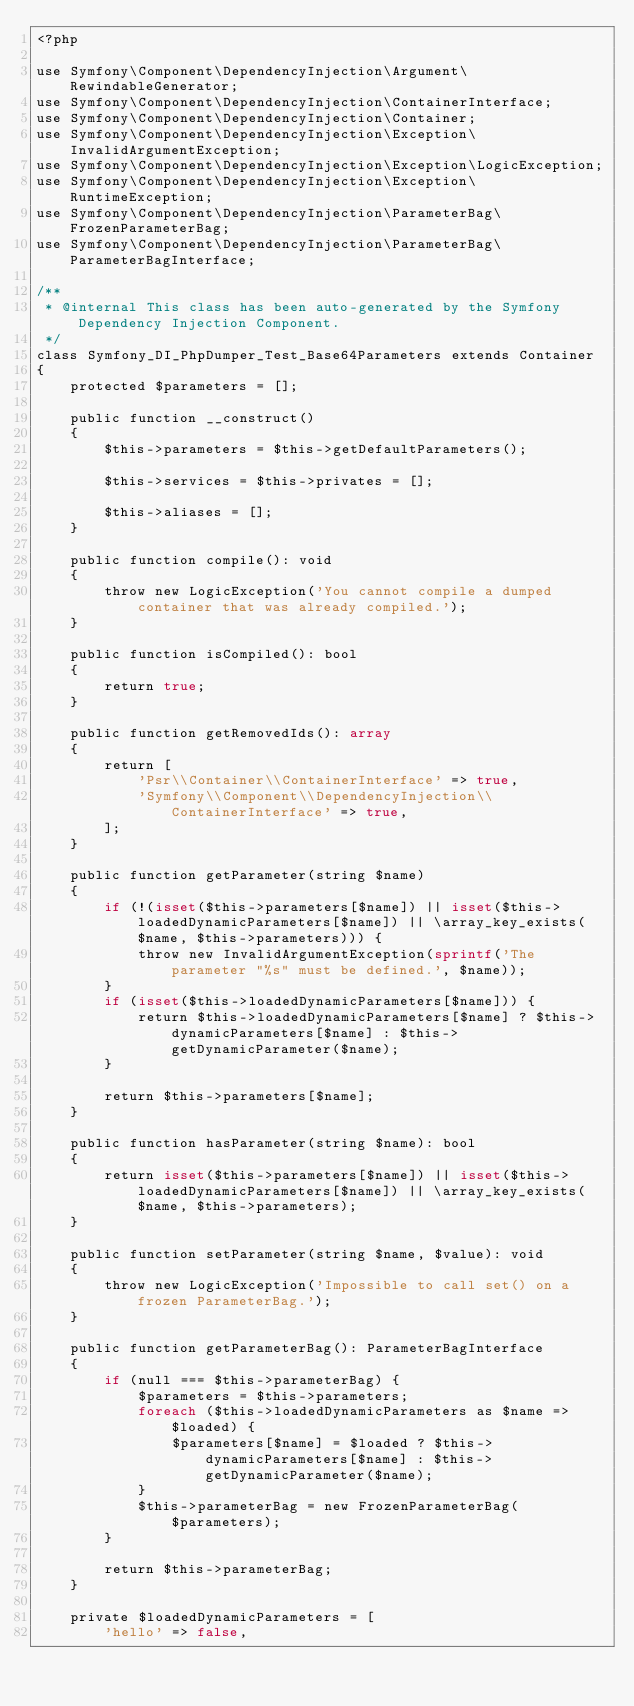<code> <loc_0><loc_0><loc_500><loc_500><_PHP_><?php

use Symfony\Component\DependencyInjection\Argument\RewindableGenerator;
use Symfony\Component\DependencyInjection\ContainerInterface;
use Symfony\Component\DependencyInjection\Container;
use Symfony\Component\DependencyInjection\Exception\InvalidArgumentException;
use Symfony\Component\DependencyInjection\Exception\LogicException;
use Symfony\Component\DependencyInjection\Exception\RuntimeException;
use Symfony\Component\DependencyInjection\ParameterBag\FrozenParameterBag;
use Symfony\Component\DependencyInjection\ParameterBag\ParameterBagInterface;

/**
 * @internal This class has been auto-generated by the Symfony Dependency Injection Component.
 */
class Symfony_DI_PhpDumper_Test_Base64Parameters extends Container
{
    protected $parameters = [];

    public function __construct()
    {
        $this->parameters = $this->getDefaultParameters();

        $this->services = $this->privates = [];

        $this->aliases = [];
    }

    public function compile(): void
    {
        throw new LogicException('You cannot compile a dumped container that was already compiled.');
    }

    public function isCompiled(): bool
    {
        return true;
    }

    public function getRemovedIds(): array
    {
        return [
            'Psr\\Container\\ContainerInterface' => true,
            'Symfony\\Component\\DependencyInjection\\ContainerInterface' => true,
        ];
    }

    public function getParameter(string $name)
    {
        if (!(isset($this->parameters[$name]) || isset($this->loadedDynamicParameters[$name]) || \array_key_exists($name, $this->parameters))) {
            throw new InvalidArgumentException(sprintf('The parameter "%s" must be defined.', $name));
        }
        if (isset($this->loadedDynamicParameters[$name])) {
            return $this->loadedDynamicParameters[$name] ? $this->dynamicParameters[$name] : $this->getDynamicParameter($name);
        }

        return $this->parameters[$name];
    }

    public function hasParameter(string $name): bool
    {
        return isset($this->parameters[$name]) || isset($this->loadedDynamicParameters[$name]) || \array_key_exists($name, $this->parameters);
    }

    public function setParameter(string $name, $value): void
    {
        throw new LogicException('Impossible to call set() on a frozen ParameterBag.');
    }

    public function getParameterBag(): ParameterBagInterface
    {
        if (null === $this->parameterBag) {
            $parameters = $this->parameters;
            foreach ($this->loadedDynamicParameters as $name => $loaded) {
                $parameters[$name] = $loaded ? $this->dynamicParameters[$name] : $this->getDynamicParameter($name);
            }
            $this->parameterBag = new FrozenParameterBag($parameters);
        }

        return $this->parameterBag;
    }

    private $loadedDynamicParameters = [
        'hello' => false,</code> 